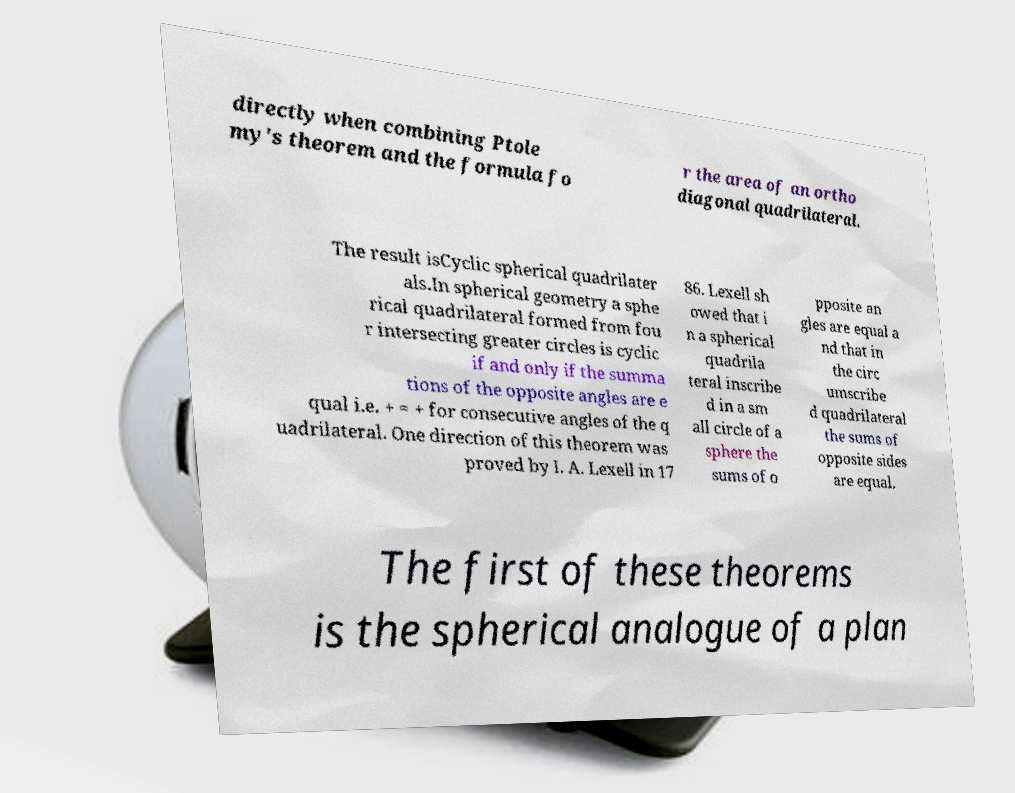For documentation purposes, I need the text within this image transcribed. Could you provide that? directly when combining Ptole my's theorem and the formula fo r the area of an ortho diagonal quadrilateral. The result isCyclic spherical quadrilater als.In spherical geometry a sphe rical quadrilateral formed from fou r intersecting greater circles is cyclic if and only if the summa tions of the opposite angles are e qual i.e. + = + for consecutive angles of the q uadrilateral. One direction of this theorem was proved by I. A. Lexell in 17 86. Lexell sh owed that i n a spherical quadrila teral inscribe d in a sm all circle of a sphere the sums of o pposite an gles are equal a nd that in the circ umscribe d quadrilateral the sums of opposite sides are equal. The first of these theorems is the spherical analogue of a plan 